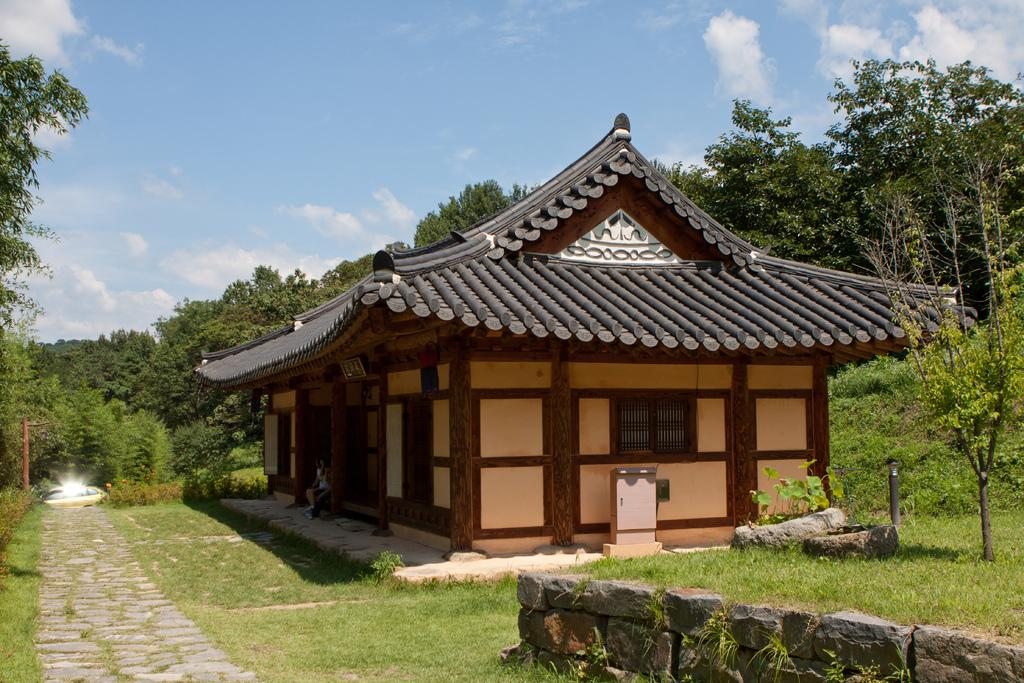What type of vegetation can be seen in the image? There is grass in the image. What type of structure is present on the ground in the image? There is a stonewall on the ground in the image. What type of building can be seen in the image? There is a house in the image. What other natural elements are present in the image? There are trees in the image. What is visible in the background of the image? The sky is visible in the background of the image. What can be observed in the sky? Clouds are present in the sky. How many screws can be seen holding the house together in the image? There are no screws visible in the image; the house appears to be a solid structure. What type of minister is present in the image? There is no minister present in the image. 